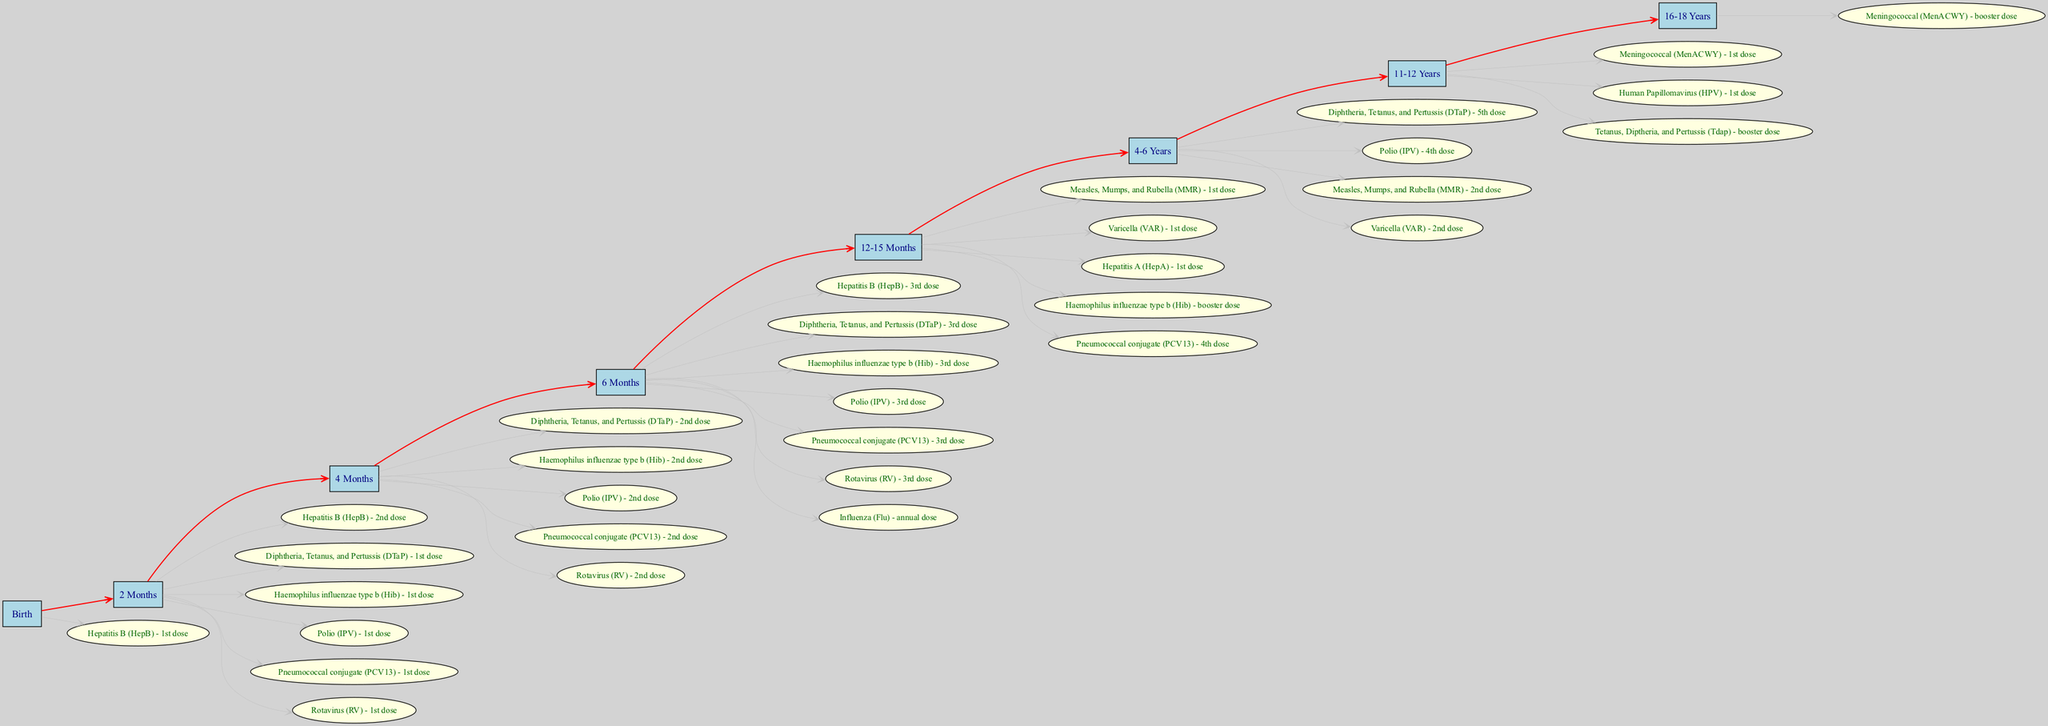What vaccinations are given at 2 months? Looking at the age milestone for 2 months in the diagram, the listed vaccinations include "Hepatitis B (HepB) - 2nd dose", "Diphtheria, Tetanus, and Pertussis (DTaP) - 1st dose", "Haemophilus influenzae type b (Hib) - 1st dose", "Polio (IPV) - 1st dose", "Pneumococcal conjugate (PCV13) - 1st dose", and "Rotavirus (RV) - 1st dose". This is a comprehensive list of all vaccinations scheduled for that age group.
Answer: Hepatitis B (HepB) - 2nd dose, Diphtheria, Tetanus, and Pertussis (DTaP) - 1st dose, Haemophilus influenzae type b (Hib) - 1st dose, Polio (IPV) - 1st dose, Pneumococcal conjugate (PCV13) - 1st dose, Rotavirus (RV) - 1st dose At what age is the first dose of the MMR vaccine given? The diagram shows that the first dose of the Measles, Mumps, and Rubella (MMR) vaccine is administered between 12 to 15 months of age. This timeline is designated specifically in the milestone for that age range in the diagram.
Answer: 12-15 Months How many vaccinations are scheduled for the 6-month milestone? In the diagram for the 6-month milestone, the listed vaccinations include seven distinct vaccines. Counting the individual vaccinations reveals that there are a total of seven vaccines scheduled at this age.
Answer: 7 What is the relationship between the 12-15 months milestone and the 4-6 years milestone? The diagram illustrates that there is a clear progression from the 12-15 months milestone to the 4-6 years milestone, with a direct edge connecting these two age milestones. This indicates that once the vaccinations at 12-15 months are completed, the child advances to the next schedule, which is at 4-6 years.
Answer: Progression What are the doses indicated for the Polio vaccine by age? The Polio vaccine doses listed in the diagram correspond to specific ages: "Polio (IPV) - 1st dose" at 2 months, "Polio (IPV) - 2nd dose" at 4 months, "Polio (IPV) - 3rd dose" at 6 months, and "Polio (IPV) - 4th dose" at 4-6 years. This outlines the scheduled doses effectively across different milestones.
Answer: 1st dose, 2nd dose, 3rd dose, 4th dose How many age milestones are identified in the vaccination schedule? By reviewing the diagram, we see that there are a total of seven age milestones presented throughout the vaccination schedule for pediatrics, from birth to 16-18 years. Counting each distinct age milestone confirms this total.
Answer: 7 